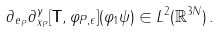Convert formula to latex. <formula><loc_0><loc_0><loc_500><loc_500>\partial _ { { e } _ { P } } \partial _ { x _ { P } } ^ { \gamma } [ { \mathbf T } , \varphi _ { P , \epsilon } ] ( \varphi _ { 1 } \psi ) \in L ^ { 2 } ( { \mathbb { R } } ^ { 3 N } ) \, .</formula> 